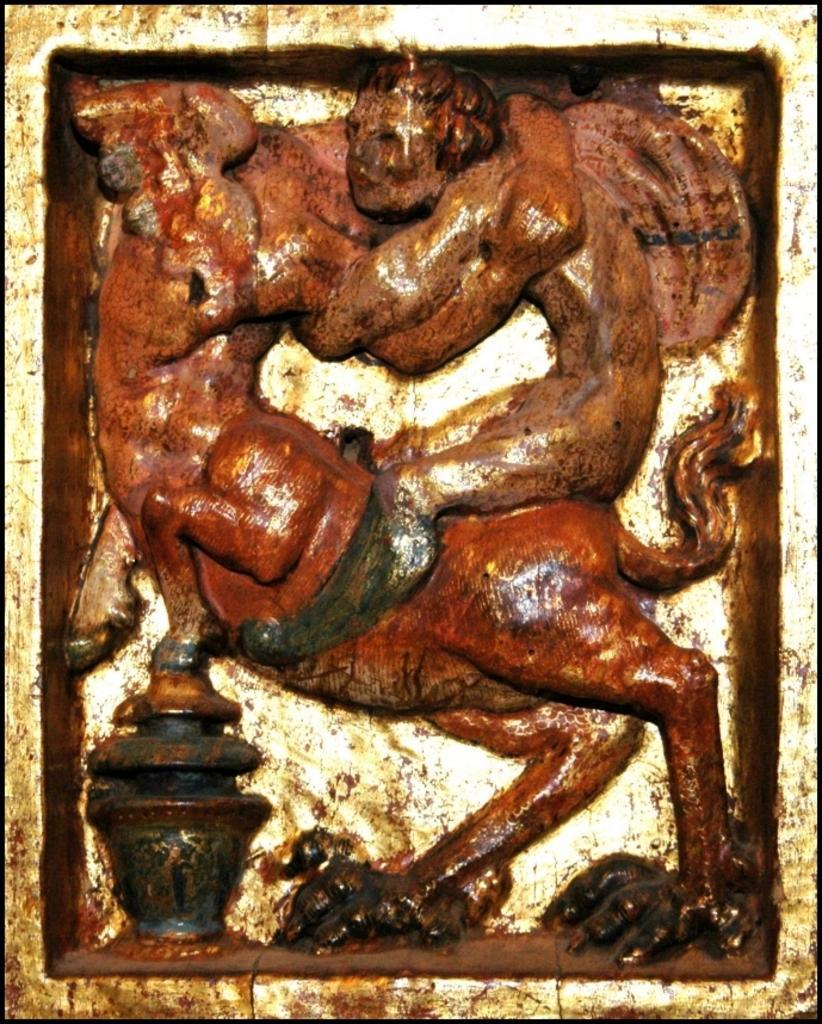Could you give a brief overview of what you see in this image? In this picture we can see a sculpture. 